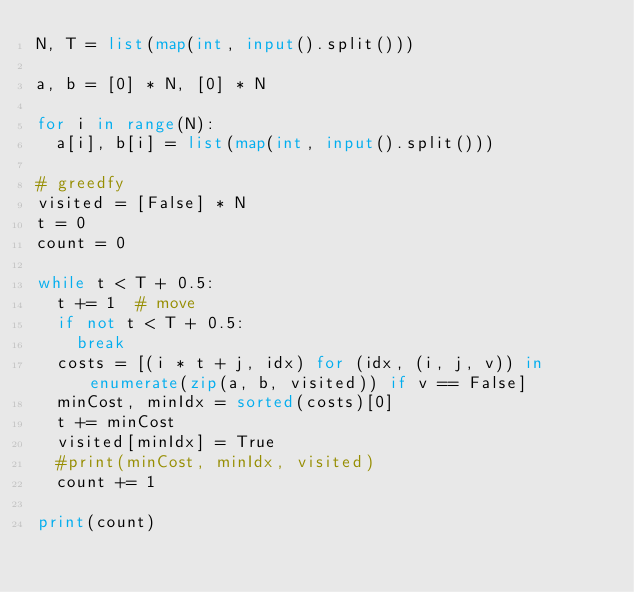<code> <loc_0><loc_0><loc_500><loc_500><_Python_>N, T = list(map(int, input().split()))

a, b = [0] * N, [0] * N

for i in range(N):
  a[i], b[i] = list(map(int, input().split()))

# greedfy
visited = [False] * N
t = 0
count = 0

while t < T + 0.5:
  t += 1  # move
  if not t < T + 0.5:
    break
  costs = [(i * t + j, idx) for (idx, (i, j, v)) in enumerate(zip(a, b, visited)) if v == False]
  minCost, minIdx = sorted(costs)[0]
  t += minCost
  visited[minIdx] = True
  #print(minCost, minIdx, visited)
  count += 1

print(count)
</code> 